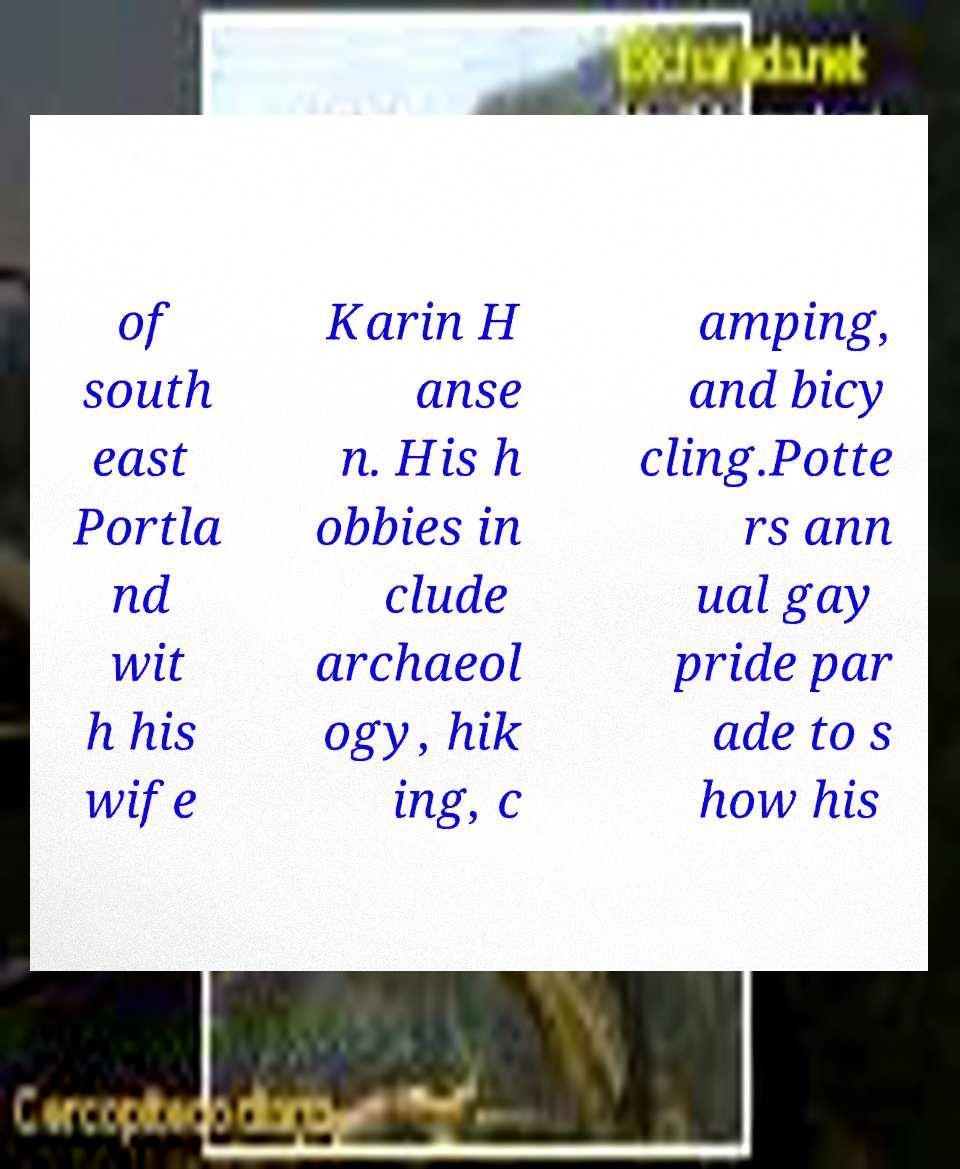There's text embedded in this image that I need extracted. Can you transcribe it verbatim? of south east Portla nd wit h his wife Karin H anse n. His h obbies in clude archaeol ogy, hik ing, c amping, and bicy cling.Potte rs ann ual gay pride par ade to s how his 